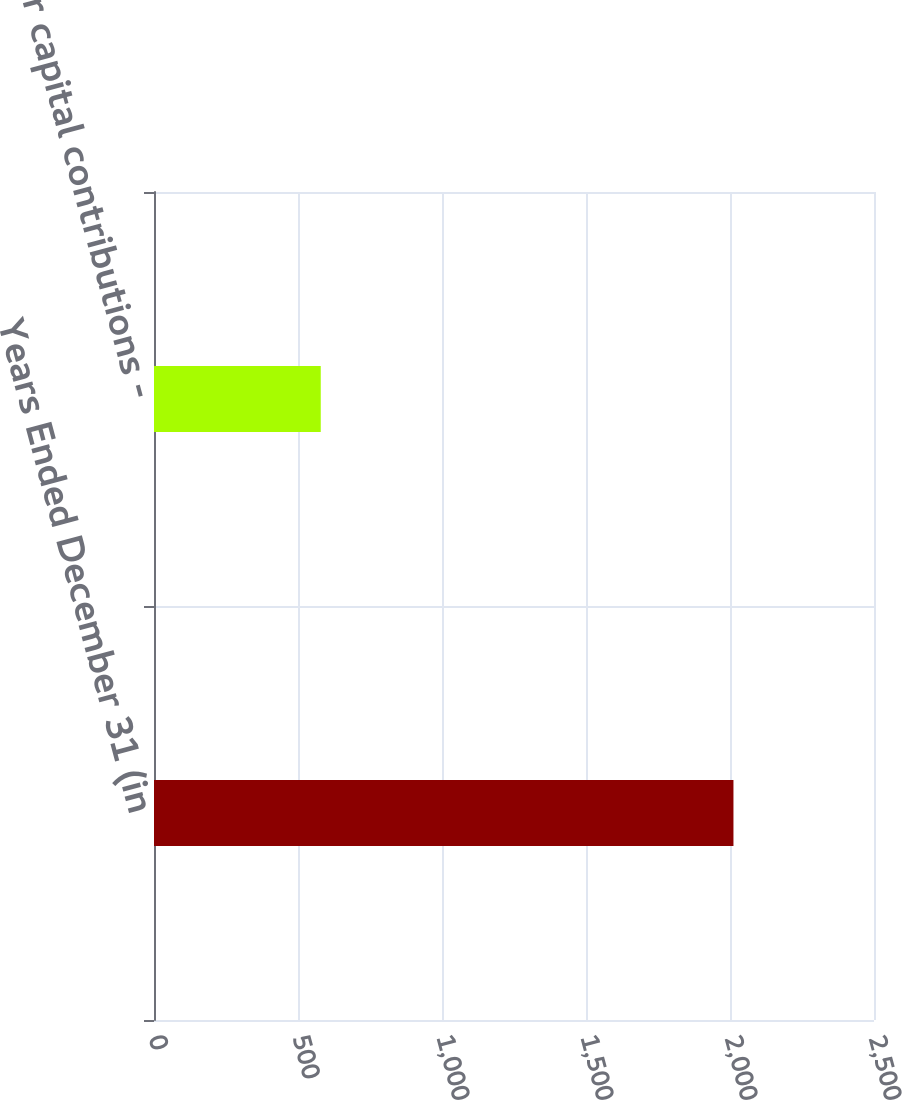<chart> <loc_0><loc_0><loc_500><loc_500><bar_chart><fcel>Years Ended December 31 (in<fcel>Other capital contributions -<nl><fcel>2012<fcel>579<nl></chart> 